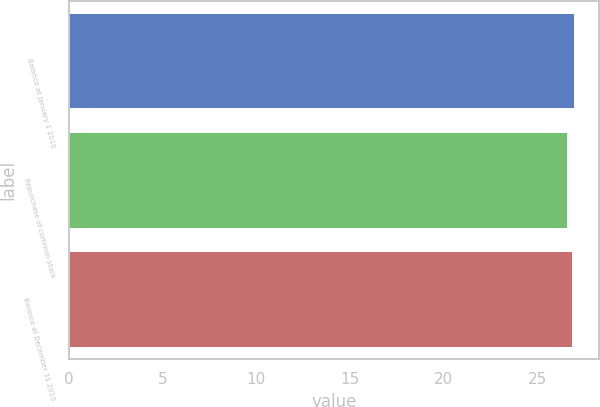Convert chart to OTSL. <chart><loc_0><loc_0><loc_500><loc_500><bar_chart><fcel>Balance at January 1 2010<fcel>Repurchase of common stock<fcel>Balance at December 31 2010<nl><fcel>26.98<fcel>26.6<fcel>26.85<nl></chart> 